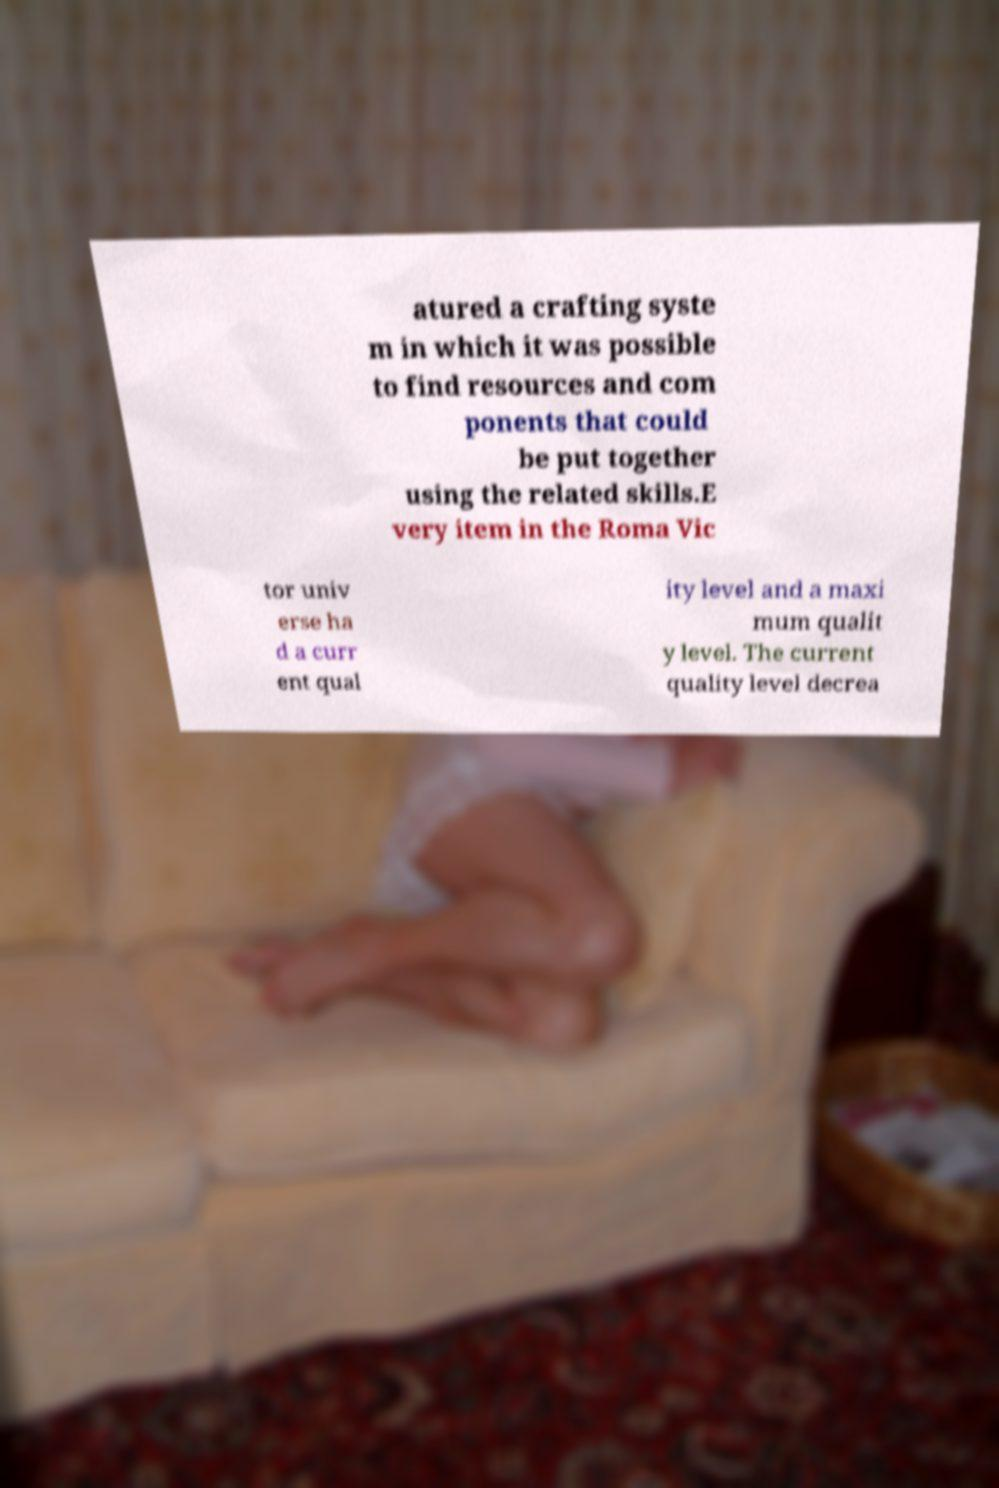What messages or text are displayed in this image? I need them in a readable, typed format. atured a crafting syste m in which it was possible to find resources and com ponents that could be put together using the related skills.E very item in the Roma Vic tor univ erse ha d a curr ent qual ity level and a maxi mum qualit y level. The current quality level decrea 